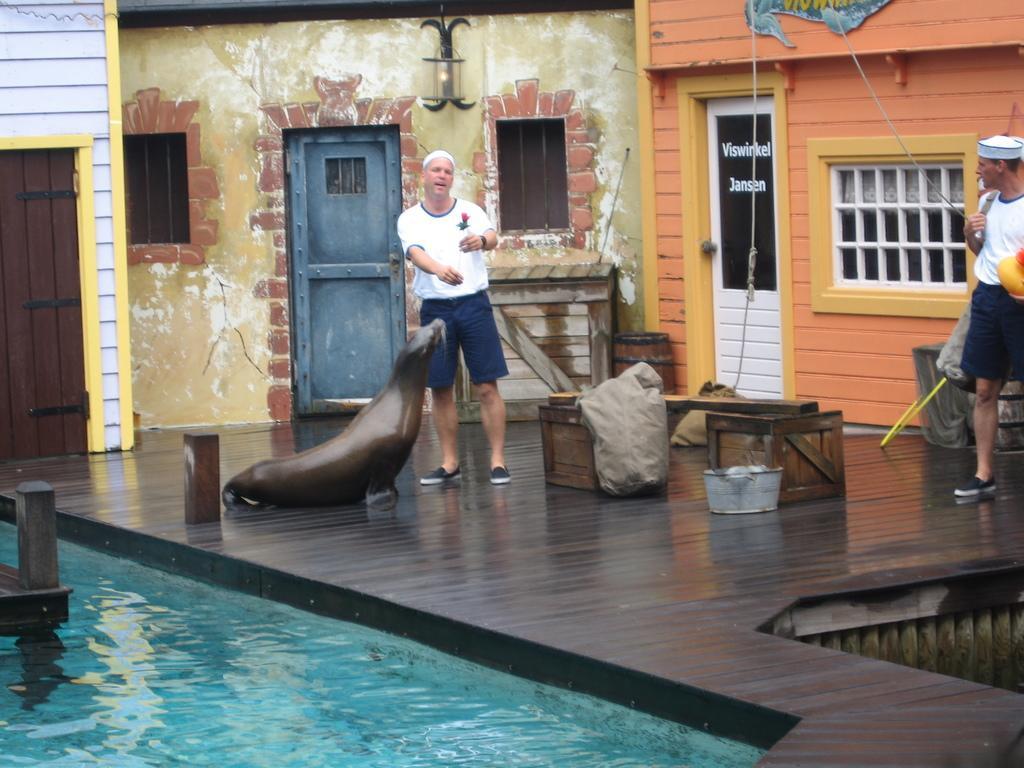How would you summarize this image in a sentence or two? In this image we can see two men are standing. They are wearing white color t-shirt with blue shorts. And one sea lion is there on the wooden surface. We can see two wooden boxes and one container. There is a pool at the bottom of the image. There are different color walls in the background with doors and windows. 